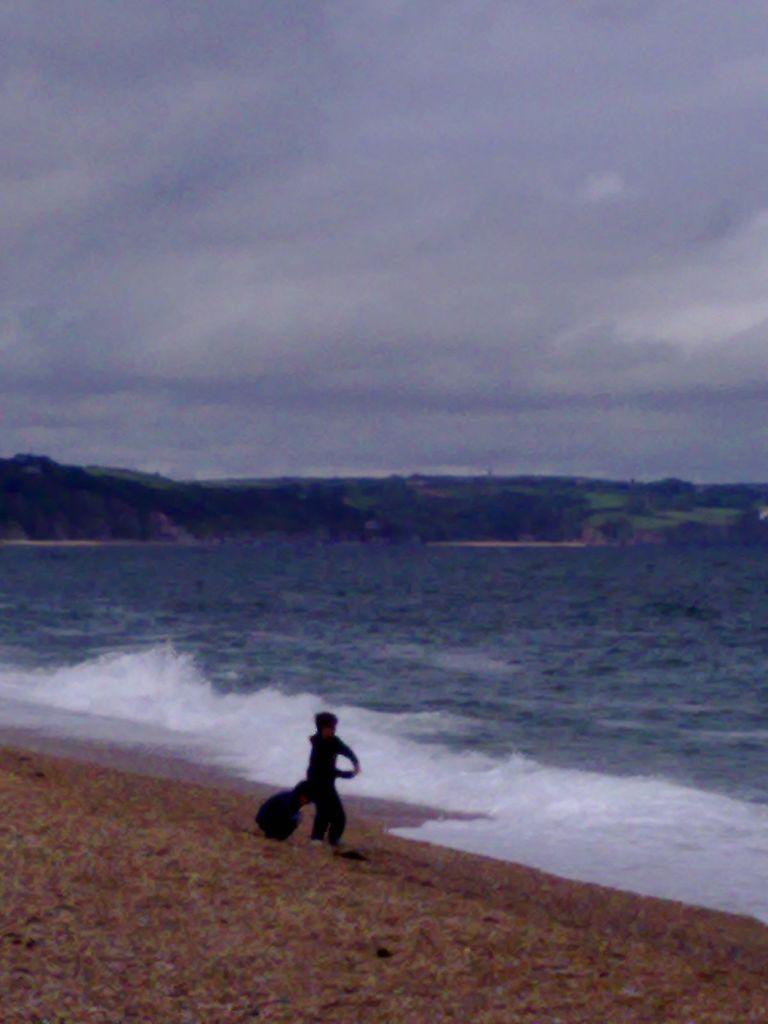Could you give a brief overview of what you see in this image? At the bottom we can see a person is standing on the ground and holding an object in the hands. In the background we can see water, trees, grass on the ground and clouds in the sky. 